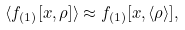Convert formula to latex. <formula><loc_0><loc_0><loc_500><loc_500>\langle f _ { ( 1 ) } [ x , \rho ] \rangle \approx f _ { ( 1 ) } [ x , \langle \rho \rangle ] ,</formula> 